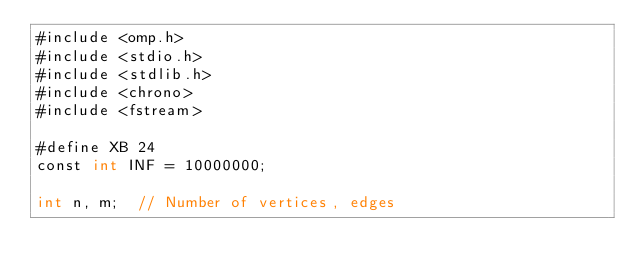Convert code to text. <code><loc_0><loc_0><loc_500><loc_500><_Cuda_>#include <omp.h>
#include <stdio.h>
#include <stdlib.h>
#include <chrono>
#include <fstream>

#define XB 24
const int INF = 10000000;

int n, m;  // Number of vertices, edges</code> 